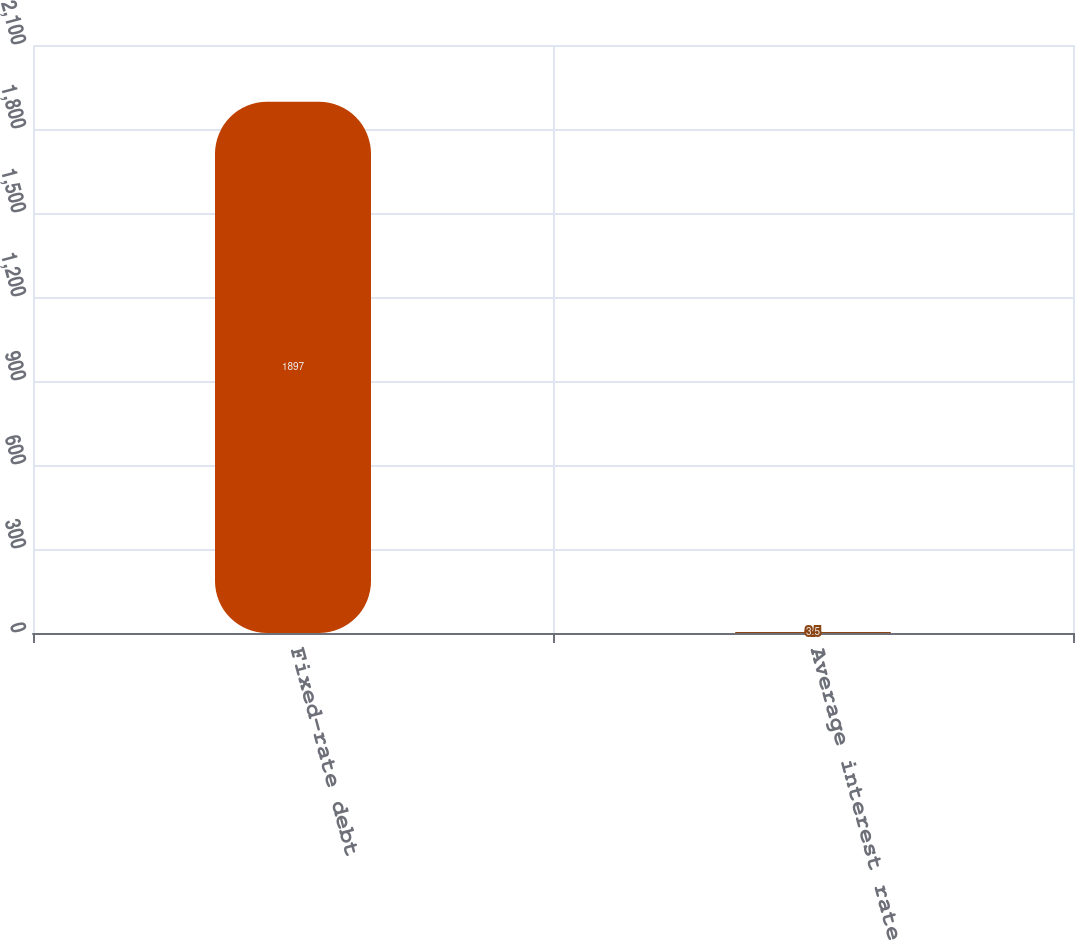Convert chart. <chart><loc_0><loc_0><loc_500><loc_500><bar_chart><fcel>Fixed-rate debt<fcel>Average interest rate<nl><fcel>1897<fcel>3.5<nl></chart> 